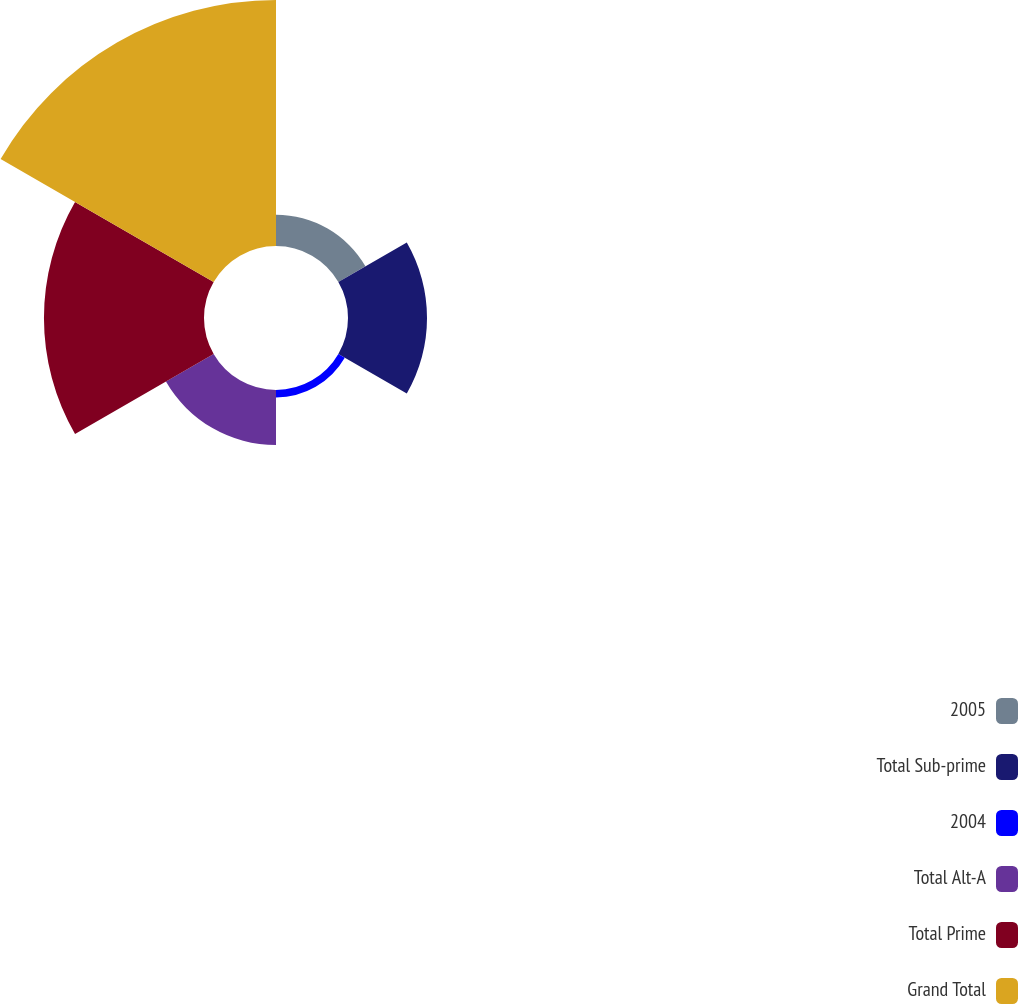Convert chart. <chart><loc_0><loc_0><loc_500><loc_500><pie_chart><fcel>2005<fcel>Total Sub-prime<fcel>2004<fcel>Total Alt-A<fcel>Total Prime<fcel>Grand Total<nl><fcel>5.4%<fcel>13.65%<fcel>1.28%<fcel>9.52%<fcel>27.65%<fcel>42.5%<nl></chart> 